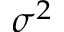<formula> <loc_0><loc_0><loc_500><loc_500>\sigma ^ { 2 }</formula> 